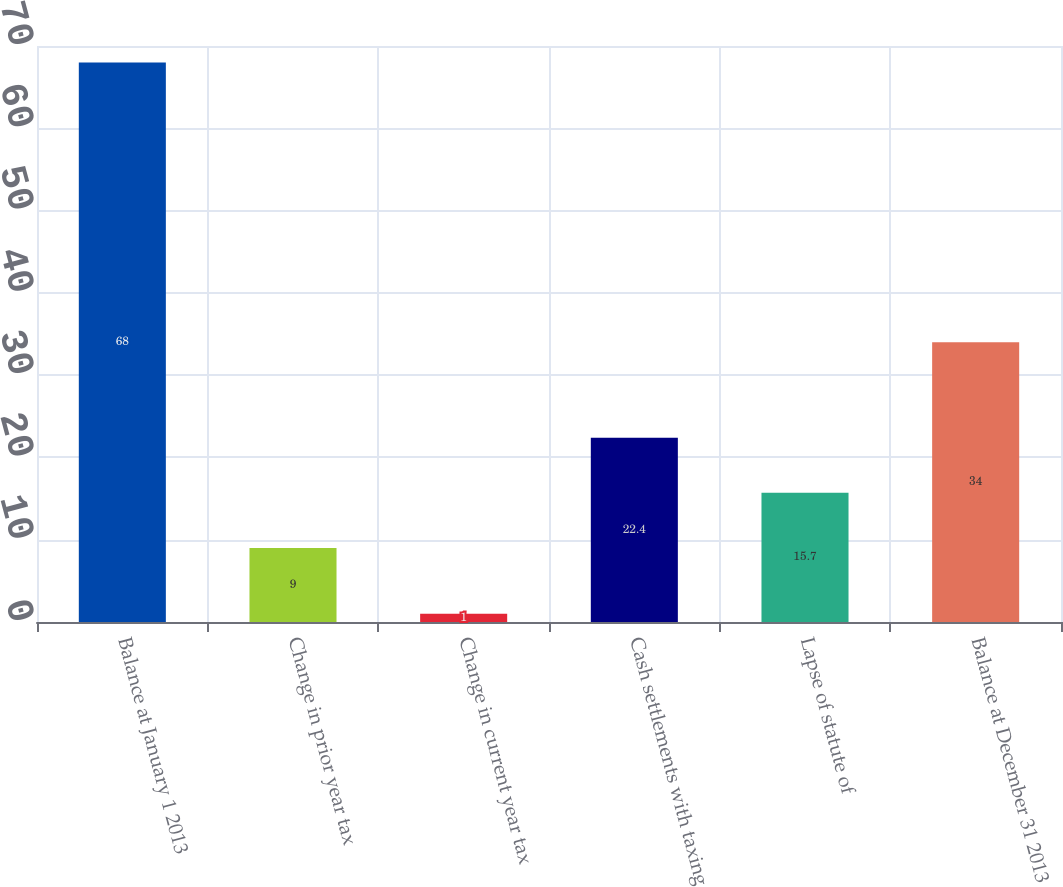Convert chart. <chart><loc_0><loc_0><loc_500><loc_500><bar_chart><fcel>Balance at January 1 2013<fcel>Change in prior year tax<fcel>Change in current year tax<fcel>Cash settlements with taxing<fcel>Lapse of statute of<fcel>Balance at December 31 2013<nl><fcel>68<fcel>9<fcel>1<fcel>22.4<fcel>15.7<fcel>34<nl></chart> 